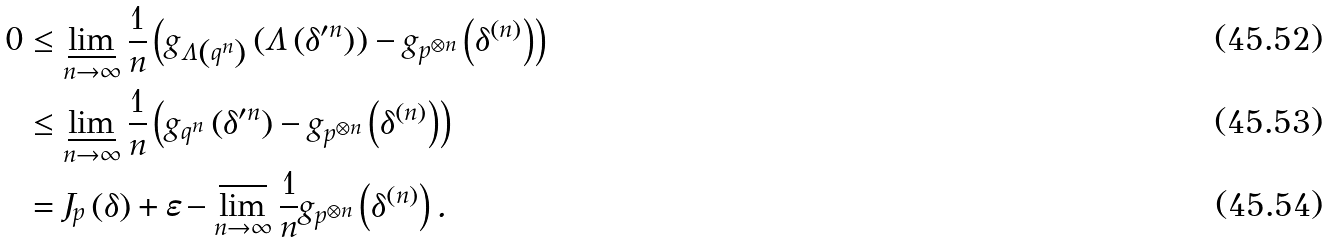Convert formula to latex. <formula><loc_0><loc_0><loc_500><loc_500>0 & \leq \varliminf _ { n \rightarrow \infty } \frac { 1 } { n } \left ( g _ { \Lambda \left ( q ^ { n } \right ) } \left ( \Lambda \left ( \delta ^ { \prime n } \right ) \right ) - g _ { p ^ { \otimes n } } \left ( \delta ^ { \left ( n \right ) } \right ) \right ) \\ & \leq \varliminf _ { n \rightarrow \infty } \frac { 1 } { n } \left ( g _ { q ^ { n } } \left ( \delta ^ { \prime n } \right ) - g _ { p ^ { \otimes n } } \left ( \delta ^ { \left ( n \right ) } \right ) \right ) \\ & = J _ { p } \left ( \delta \right ) + \varepsilon - \varlimsup _ { n \rightarrow \infty } \frac { 1 } { n } g _ { p ^ { \otimes n } } \left ( \delta ^ { \left ( n \right ) } \right ) .</formula> 